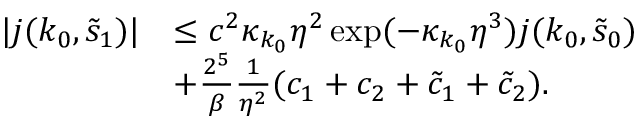<formula> <loc_0><loc_0><loc_500><loc_500>\begin{array} { r l } { | j ( k _ { 0 } , \tilde { s } _ { 1 } ) | } & { \leq c ^ { 2 } \kappa _ { k _ { 0 } } \eta ^ { 2 } \exp ( - \kappa _ { k _ { 0 } } \eta ^ { 3 } ) j ( k _ { 0 } , \tilde { s } _ { 0 } ) } \\ & { + \frac { 2 ^ { 5 } } \beta \frac { 1 } \eta ^ { 2 } } ( c _ { 1 } + c _ { 2 } + \tilde { c } _ { 1 } + \tilde { c } _ { 2 } ) . } \end{array}</formula> 